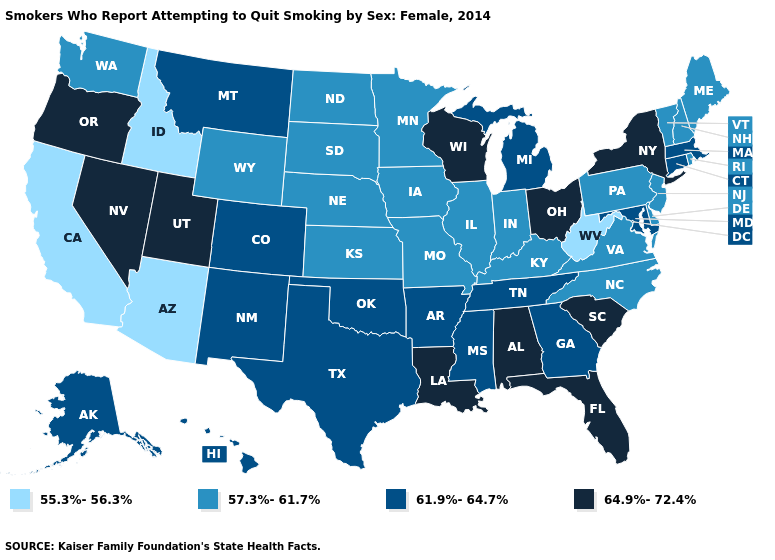What is the lowest value in the West?
Answer briefly. 55.3%-56.3%. What is the value of Oklahoma?
Short answer required. 61.9%-64.7%. What is the value of North Dakota?
Be succinct. 57.3%-61.7%. Name the states that have a value in the range 64.9%-72.4%?
Answer briefly. Alabama, Florida, Louisiana, Nevada, New York, Ohio, Oregon, South Carolina, Utah, Wisconsin. Name the states that have a value in the range 55.3%-56.3%?
Be succinct. Arizona, California, Idaho, West Virginia. Name the states that have a value in the range 61.9%-64.7%?
Quick response, please. Alaska, Arkansas, Colorado, Connecticut, Georgia, Hawaii, Maryland, Massachusetts, Michigan, Mississippi, Montana, New Mexico, Oklahoma, Tennessee, Texas. Among the states that border Louisiana , which have the highest value?
Keep it brief. Arkansas, Mississippi, Texas. Does the first symbol in the legend represent the smallest category?
Short answer required. Yes. Name the states that have a value in the range 64.9%-72.4%?
Concise answer only. Alabama, Florida, Louisiana, Nevada, New York, Ohio, Oregon, South Carolina, Utah, Wisconsin. Name the states that have a value in the range 57.3%-61.7%?
Be succinct. Delaware, Illinois, Indiana, Iowa, Kansas, Kentucky, Maine, Minnesota, Missouri, Nebraska, New Hampshire, New Jersey, North Carolina, North Dakota, Pennsylvania, Rhode Island, South Dakota, Vermont, Virginia, Washington, Wyoming. What is the value of Massachusetts?
Short answer required. 61.9%-64.7%. Name the states that have a value in the range 57.3%-61.7%?
Write a very short answer. Delaware, Illinois, Indiana, Iowa, Kansas, Kentucky, Maine, Minnesota, Missouri, Nebraska, New Hampshire, New Jersey, North Carolina, North Dakota, Pennsylvania, Rhode Island, South Dakota, Vermont, Virginia, Washington, Wyoming. Does Mississippi have a higher value than Arkansas?
Keep it brief. No. What is the highest value in states that border Rhode Island?
Quick response, please. 61.9%-64.7%. Among the states that border North Carolina , does Tennessee have the lowest value?
Short answer required. No. 